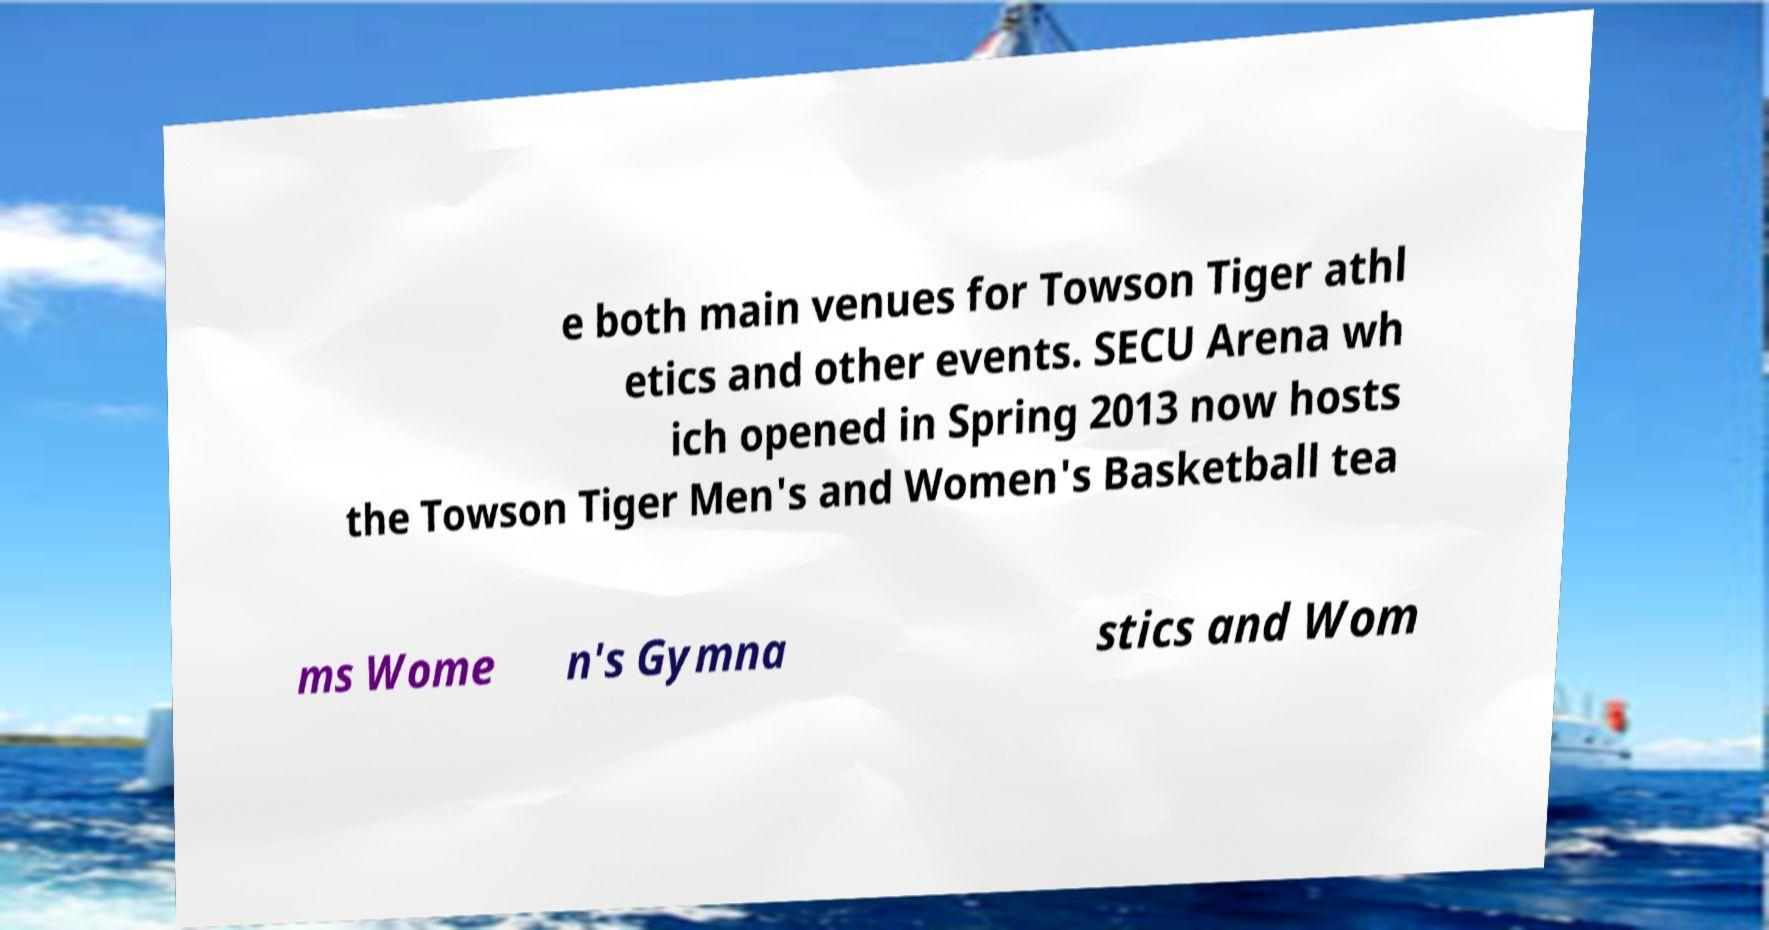For documentation purposes, I need the text within this image transcribed. Could you provide that? e both main venues for Towson Tiger athl etics and other events. SECU Arena wh ich opened in Spring 2013 now hosts the Towson Tiger Men's and Women's Basketball tea ms Wome n's Gymna stics and Wom 